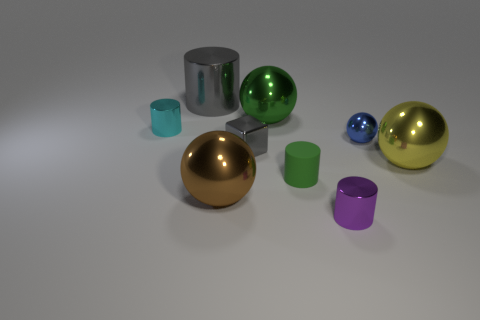Can you tell me what the different colors of the spheres might represent? While the spheres do not inherently represent anything specific, their varied colors—golden, green, and blue—could be used to symbolize different concepts such as elements of nature or levels or values within a system due to their different hues and finish. 